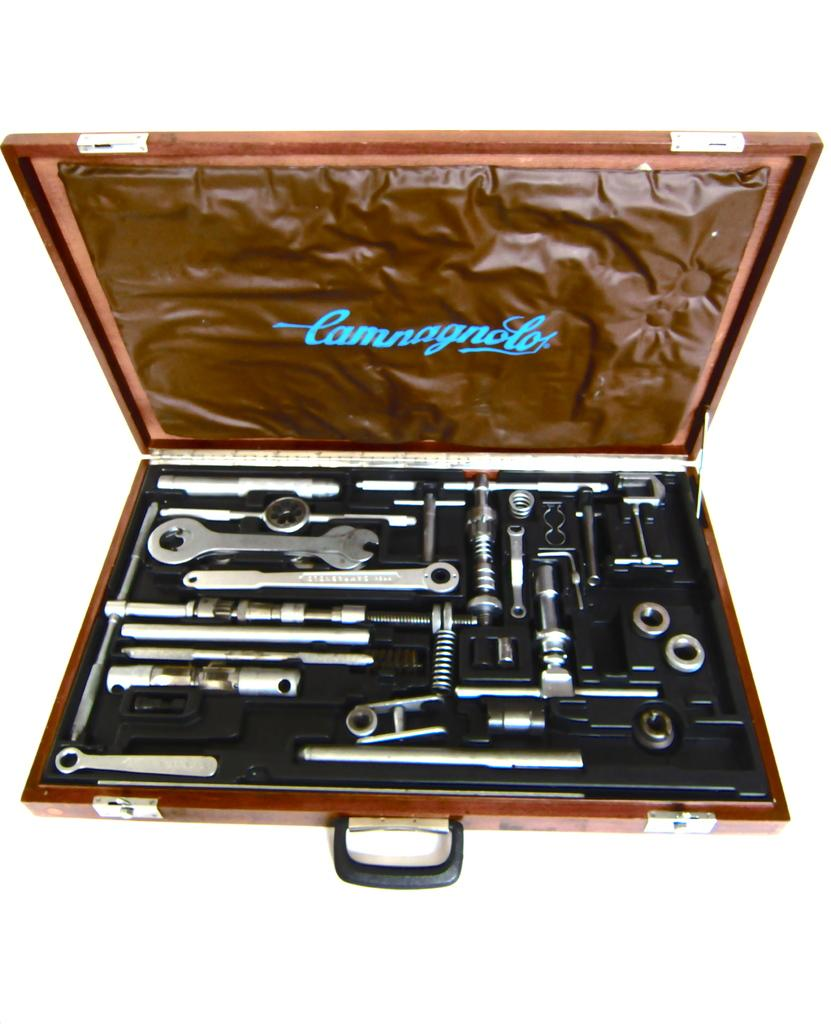What object can be seen in the image? There is a toolbox in the image. What is inside the toolbox? The toolbox contains various tools. What type of powder is being used to attract attention in the image? There is no powder or attention-seeking activity present in the image; it only features a toolbox with various tools. 